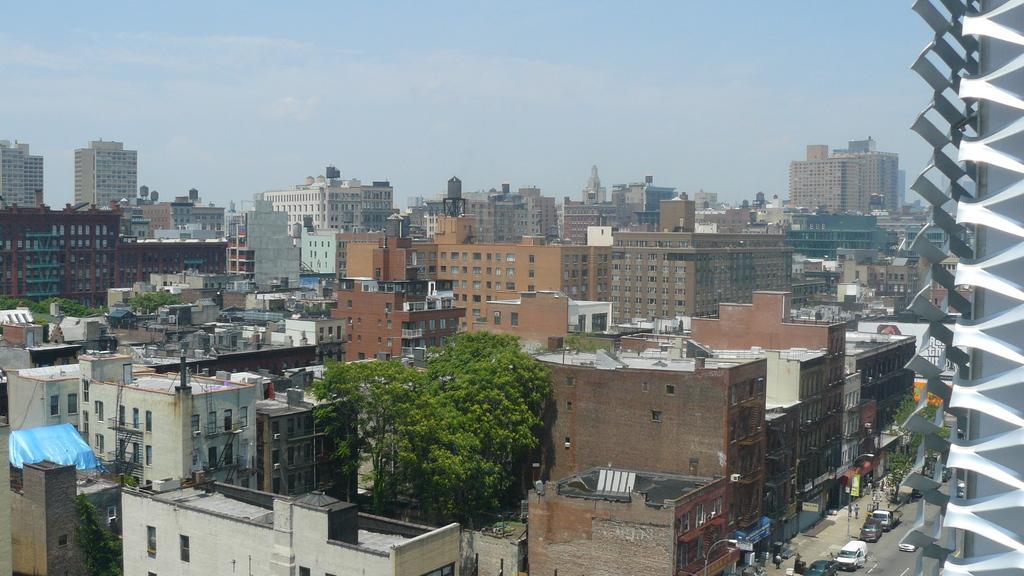In one or two sentences, can you explain what this image depicts? This is the picture of a city. In this image there are buildings and trees. At the top there is sky and there are clouds. At the bottom there are vehicles and there are group of people on the road. 